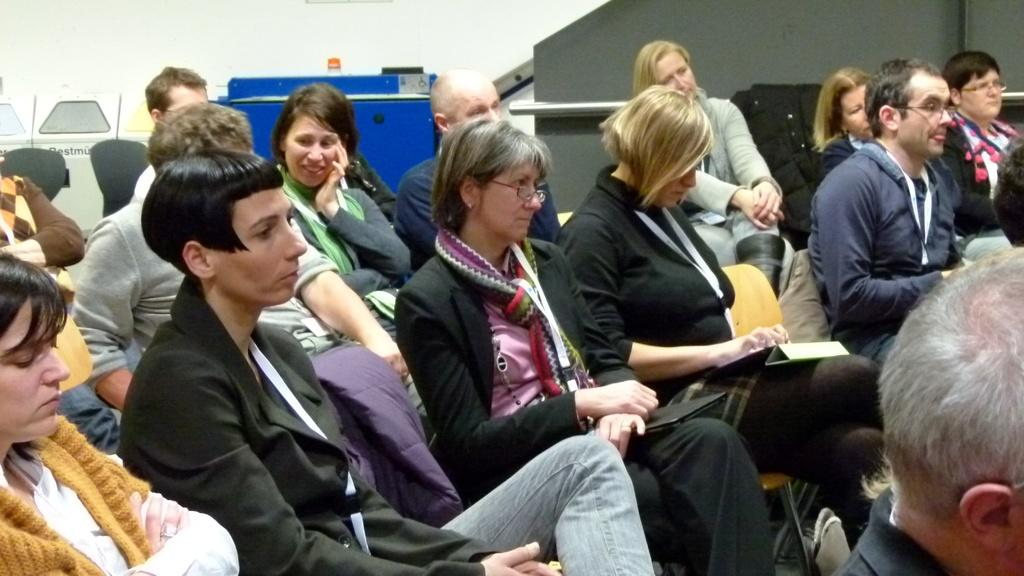What are the people in the room doing? The people in the room are sitting on chairs. Are the people holding anything? Some people are carrying things. What can be seen in the background of the room? There are objects visible in the background. How many cribs are in the room? There is no mention of a crib in the image, so it cannot be determined if any are present. 